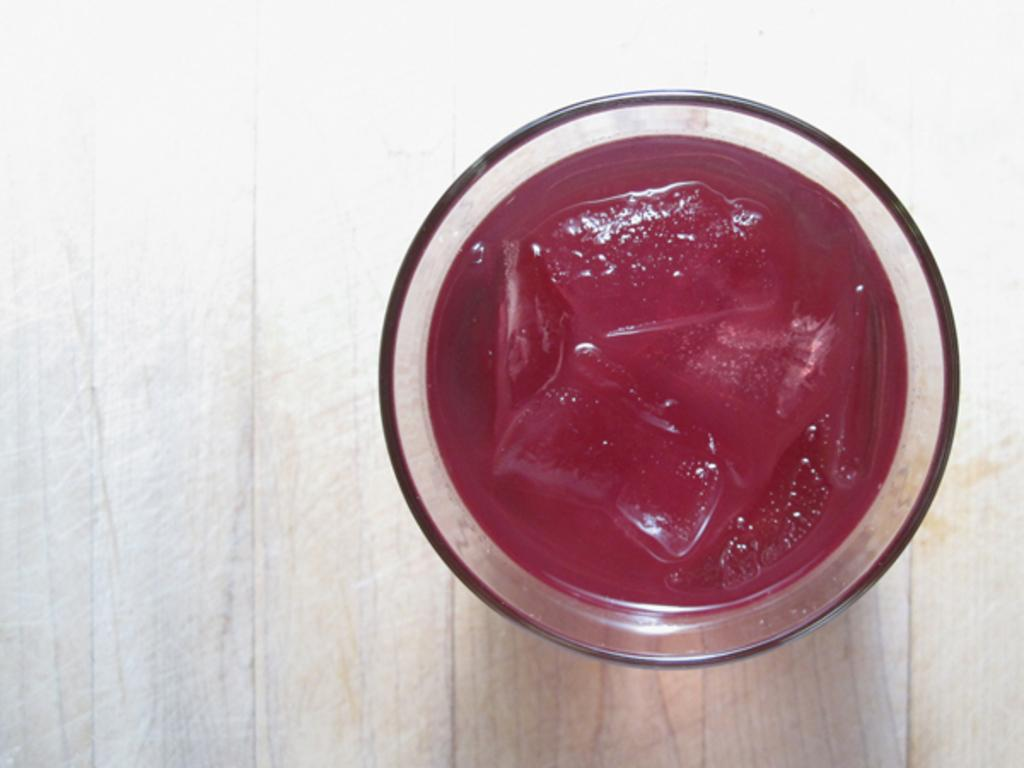What object is present in the image that can hold a liquid? There is a glass in the image that can hold a liquid. What is on the glass in the image? There is a red color thing on the glass. What is the color of the surface the glass is placed on? The glass is placed on a white and light brown color surface. How many feet are visible in the image? There are no feet visible in the image. What type of brush is used for painting the glass in the image? There is no indication that the glass in the image has been painted, and therefore no brush is involved. 